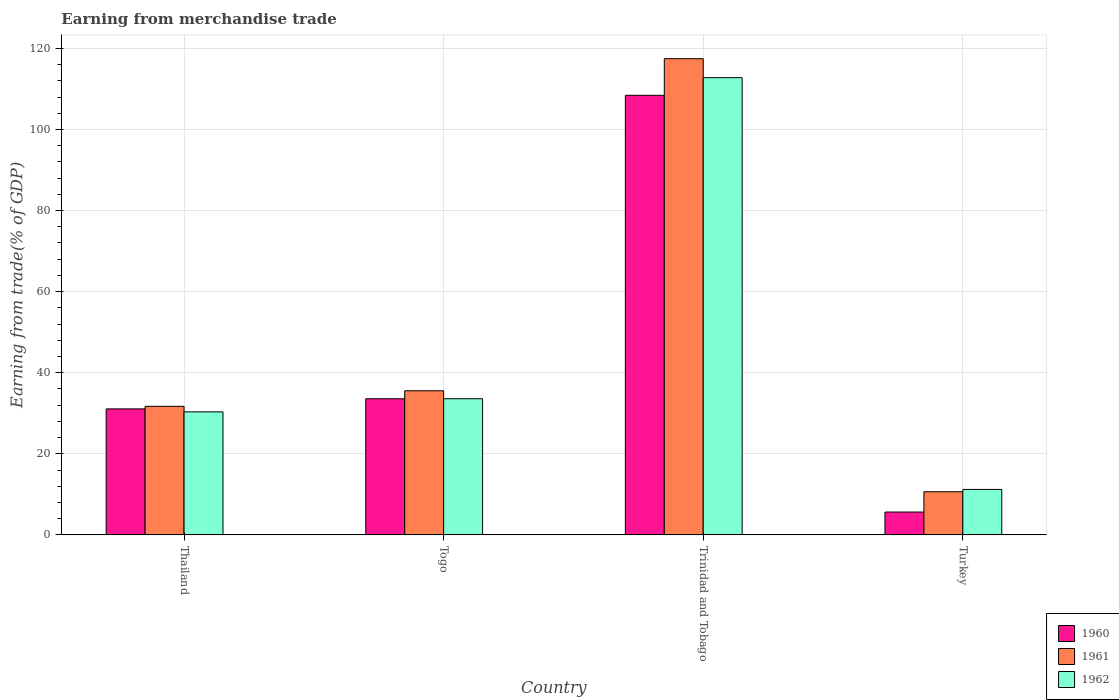How many different coloured bars are there?
Provide a succinct answer. 3. How many groups of bars are there?
Provide a short and direct response. 4. Are the number of bars per tick equal to the number of legend labels?
Ensure brevity in your answer.  Yes. How many bars are there on the 2nd tick from the left?
Your response must be concise. 3. How many bars are there on the 2nd tick from the right?
Provide a short and direct response. 3. What is the label of the 1st group of bars from the left?
Keep it short and to the point. Thailand. In how many cases, is the number of bars for a given country not equal to the number of legend labels?
Your answer should be very brief. 0. What is the earnings from trade in 1962 in Togo?
Ensure brevity in your answer.  33.58. Across all countries, what is the maximum earnings from trade in 1961?
Your response must be concise. 117.45. Across all countries, what is the minimum earnings from trade in 1962?
Ensure brevity in your answer.  11.21. In which country was the earnings from trade in 1960 maximum?
Make the answer very short. Trinidad and Tobago. In which country was the earnings from trade in 1962 minimum?
Ensure brevity in your answer.  Turkey. What is the total earnings from trade in 1960 in the graph?
Ensure brevity in your answer.  178.71. What is the difference between the earnings from trade in 1961 in Thailand and that in Turkey?
Provide a succinct answer. 21.06. What is the difference between the earnings from trade in 1961 in Turkey and the earnings from trade in 1962 in Togo?
Provide a short and direct response. -22.94. What is the average earnings from trade in 1962 per country?
Offer a very short reply. 46.98. What is the difference between the earnings from trade of/in 1962 and earnings from trade of/in 1961 in Togo?
Your response must be concise. -1.96. In how many countries, is the earnings from trade in 1962 greater than 8 %?
Give a very brief answer. 4. What is the ratio of the earnings from trade in 1962 in Togo to that in Trinidad and Tobago?
Make the answer very short. 0.3. What is the difference between the highest and the second highest earnings from trade in 1960?
Offer a very short reply. -74.84. What is the difference between the highest and the lowest earnings from trade in 1961?
Your answer should be very brief. 106.81. Is the sum of the earnings from trade in 1960 in Thailand and Trinidad and Tobago greater than the maximum earnings from trade in 1961 across all countries?
Your response must be concise. Yes. What does the 1st bar from the left in Thailand represents?
Make the answer very short. 1960. What does the 1st bar from the right in Thailand represents?
Make the answer very short. 1962. Does the graph contain any zero values?
Your answer should be very brief. No. Does the graph contain grids?
Offer a terse response. Yes. Where does the legend appear in the graph?
Your answer should be very brief. Bottom right. How many legend labels are there?
Make the answer very short. 3. What is the title of the graph?
Your answer should be very brief. Earning from merchandise trade. Does "2009" appear as one of the legend labels in the graph?
Your answer should be very brief. No. What is the label or title of the X-axis?
Give a very brief answer. Country. What is the label or title of the Y-axis?
Provide a short and direct response. Earning from trade(% of GDP). What is the Earning from trade(% of GDP) in 1960 in Thailand?
Provide a succinct answer. 31.08. What is the Earning from trade(% of GDP) of 1961 in Thailand?
Make the answer very short. 31.71. What is the Earning from trade(% of GDP) of 1962 in Thailand?
Offer a terse response. 30.34. What is the Earning from trade(% of GDP) of 1960 in Togo?
Give a very brief answer. 33.58. What is the Earning from trade(% of GDP) in 1961 in Togo?
Your answer should be very brief. 35.55. What is the Earning from trade(% of GDP) of 1962 in Togo?
Provide a short and direct response. 33.58. What is the Earning from trade(% of GDP) of 1960 in Trinidad and Tobago?
Your answer should be very brief. 108.42. What is the Earning from trade(% of GDP) in 1961 in Trinidad and Tobago?
Offer a very short reply. 117.45. What is the Earning from trade(% of GDP) in 1962 in Trinidad and Tobago?
Make the answer very short. 112.77. What is the Earning from trade(% of GDP) of 1960 in Turkey?
Offer a very short reply. 5.64. What is the Earning from trade(% of GDP) in 1961 in Turkey?
Provide a short and direct response. 10.64. What is the Earning from trade(% of GDP) in 1962 in Turkey?
Make the answer very short. 11.21. Across all countries, what is the maximum Earning from trade(% of GDP) in 1960?
Offer a very short reply. 108.42. Across all countries, what is the maximum Earning from trade(% of GDP) of 1961?
Your answer should be compact. 117.45. Across all countries, what is the maximum Earning from trade(% of GDP) of 1962?
Make the answer very short. 112.77. Across all countries, what is the minimum Earning from trade(% of GDP) in 1960?
Your response must be concise. 5.64. Across all countries, what is the minimum Earning from trade(% of GDP) of 1961?
Your response must be concise. 10.64. Across all countries, what is the minimum Earning from trade(% of GDP) of 1962?
Make the answer very short. 11.21. What is the total Earning from trade(% of GDP) of 1960 in the graph?
Provide a succinct answer. 178.71. What is the total Earning from trade(% of GDP) of 1961 in the graph?
Offer a very short reply. 195.35. What is the total Earning from trade(% of GDP) in 1962 in the graph?
Provide a short and direct response. 187.91. What is the difference between the Earning from trade(% of GDP) in 1960 in Thailand and that in Togo?
Ensure brevity in your answer.  -2.5. What is the difference between the Earning from trade(% of GDP) of 1961 in Thailand and that in Togo?
Your answer should be very brief. -3.84. What is the difference between the Earning from trade(% of GDP) of 1962 in Thailand and that in Togo?
Your answer should be compact. -3.24. What is the difference between the Earning from trade(% of GDP) in 1960 in Thailand and that in Trinidad and Tobago?
Provide a succinct answer. -77.34. What is the difference between the Earning from trade(% of GDP) in 1961 in Thailand and that in Trinidad and Tobago?
Ensure brevity in your answer.  -85.74. What is the difference between the Earning from trade(% of GDP) in 1962 in Thailand and that in Trinidad and Tobago?
Make the answer very short. -82.43. What is the difference between the Earning from trade(% of GDP) in 1960 in Thailand and that in Turkey?
Keep it short and to the point. 25.44. What is the difference between the Earning from trade(% of GDP) in 1961 in Thailand and that in Turkey?
Provide a short and direct response. 21.06. What is the difference between the Earning from trade(% of GDP) of 1962 in Thailand and that in Turkey?
Offer a terse response. 19.13. What is the difference between the Earning from trade(% of GDP) of 1960 in Togo and that in Trinidad and Tobago?
Provide a succinct answer. -74.84. What is the difference between the Earning from trade(% of GDP) in 1961 in Togo and that in Trinidad and Tobago?
Ensure brevity in your answer.  -81.9. What is the difference between the Earning from trade(% of GDP) in 1962 in Togo and that in Trinidad and Tobago?
Keep it short and to the point. -79.19. What is the difference between the Earning from trade(% of GDP) in 1960 in Togo and that in Turkey?
Offer a terse response. 27.94. What is the difference between the Earning from trade(% of GDP) in 1961 in Togo and that in Turkey?
Keep it short and to the point. 24.9. What is the difference between the Earning from trade(% of GDP) in 1962 in Togo and that in Turkey?
Your answer should be very brief. 22.37. What is the difference between the Earning from trade(% of GDP) of 1960 in Trinidad and Tobago and that in Turkey?
Keep it short and to the point. 102.78. What is the difference between the Earning from trade(% of GDP) of 1961 in Trinidad and Tobago and that in Turkey?
Your answer should be compact. 106.81. What is the difference between the Earning from trade(% of GDP) in 1962 in Trinidad and Tobago and that in Turkey?
Your answer should be very brief. 101.56. What is the difference between the Earning from trade(% of GDP) in 1960 in Thailand and the Earning from trade(% of GDP) in 1961 in Togo?
Provide a short and direct response. -4.47. What is the difference between the Earning from trade(% of GDP) in 1960 in Thailand and the Earning from trade(% of GDP) in 1962 in Togo?
Ensure brevity in your answer.  -2.51. What is the difference between the Earning from trade(% of GDP) of 1961 in Thailand and the Earning from trade(% of GDP) of 1962 in Togo?
Your answer should be compact. -1.88. What is the difference between the Earning from trade(% of GDP) of 1960 in Thailand and the Earning from trade(% of GDP) of 1961 in Trinidad and Tobago?
Provide a short and direct response. -86.37. What is the difference between the Earning from trade(% of GDP) in 1960 in Thailand and the Earning from trade(% of GDP) in 1962 in Trinidad and Tobago?
Your response must be concise. -81.69. What is the difference between the Earning from trade(% of GDP) of 1961 in Thailand and the Earning from trade(% of GDP) of 1962 in Trinidad and Tobago?
Provide a succinct answer. -81.07. What is the difference between the Earning from trade(% of GDP) of 1960 in Thailand and the Earning from trade(% of GDP) of 1961 in Turkey?
Offer a very short reply. 20.43. What is the difference between the Earning from trade(% of GDP) of 1960 in Thailand and the Earning from trade(% of GDP) of 1962 in Turkey?
Your answer should be very brief. 19.86. What is the difference between the Earning from trade(% of GDP) in 1961 in Thailand and the Earning from trade(% of GDP) in 1962 in Turkey?
Give a very brief answer. 20.49. What is the difference between the Earning from trade(% of GDP) in 1960 in Togo and the Earning from trade(% of GDP) in 1961 in Trinidad and Tobago?
Ensure brevity in your answer.  -83.87. What is the difference between the Earning from trade(% of GDP) in 1960 in Togo and the Earning from trade(% of GDP) in 1962 in Trinidad and Tobago?
Keep it short and to the point. -79.19. What is the difference between the Earning from trade(% of GDP) of 1961 in Togo and the Earning from trade(% of GDP) of 1962 in Trinidad and Tobago?
Provide a succinct answer. -77.23. What is the difference between the Earning from trade(% of GDP) of 1960 in Togo and the Earning from trade(% of GDP) of 1961 in Turkey?
Your answer should be compact. 22.93. What is the difference between the Earning from trade(% of GDP) in 1960 in Togo and the Earning from trade(% of GDP) in 1962 in Turkey?
Your answer should be compact. 22.36. What is the difference between the Earning from trade(% of GDP) in 1961 in Togo and the Earning from trade(% of GDP) in 1962 in Turkey?
Provide a short and direct response. 24.33. What is the difference between the Earning from trade(% of GDP) of 1960 in Trinidad and Tobago and the Earning from trade(% of GDP) of 1961 in Turkey?
Your answer should be compact. 97.77. What is the difference between the Earning from trade(% of GDP) in 1960 in Trinidad and Tobago and the Earning from trade(% of GDP) in 1962 in Turkey?
Provide a succinct answer. 97.2. What is the difference between the Earning from trade(% of GDP) of 1961 in Trinidad and Tobago and the Earning from trade(% of GDP) of 1962 in Turkey?
Give a very brief answer. 106.24. What is the average Earning from trade(% of GDP) of 1960 per country?
Keep it short and to the point. 44.68. What is the average Earning from trade(% of GDP) of 1961 per country?
Your response must be concise. 48.84. What is the average Earning from trade(% of GDP) in 1962 per country?
Offer a very short reply. 46.98. What is the difference between the Earning from trade(% of GDP) in 1960 and Earning from trade(% of GDP) in 1961 in Thailand?
Offer a very short reply. -0.63. What is the difference between the Earning from trade(% of GDP) of 1960 and Earning from trade(% of GDP) of 1962 in Thailand?
Ensure brevity in your answer.  0.74. What is the difference between the Earning from trade(% of GDP) of 1961 and Earning from trade(% of GDP) of 1962 in Thailand?
Provide a succinct answer. 1.36. What is the difference between the Earning from trade(% of GDP) in 1960 and Earning from trade(% of GDP) in 1961 in Togo?
Your response must be concise. -1.97. What is the difference between the Earning from trade(% of GDP) in 1960 and Earning from trade(% of GDP) in 1962 in Togo?
Ensure brevity in your answer.  -0.01. What is the difference between the Earning from trade(% of GDP) in 1961 and Earning from trade(% of GDP) in 1962 in Togo?
Offer a very short reply. 1.96. What is the difference between the Earning from trade(% of GDP) in 1960 and Earning from trade(% of GDP) in 1961 in Trinidad and Tobago?
Your answer should be very brief. -9.03. What is the difference between the Earning from trade(% of GDP) in 1960 and Earning from trade(% of GDP) in 1962 in Trinidad and Tobago?
Make the answer very short. -4.35. What is the difference between the Earning from trade(% of GDP) of 1961 and Earning from trade(% of GDP) of 1962 in Trinidad and Tobago?
Offer a terse response. 4.68. What is the difference between the Earning from trade(% of GDP) of 1960 and Earning from trade(% of GDP) of 1961 in Turkey?
Offer a terse response. -5.01. What is the difference between the Earning from trade(% of GDP) of 1960 and Earning from trade(% of GDP) of 1962 in Turkey?
Provide a short and direct response. -5.58. What is the difference between the Earning from trade(% of GDP) in 1961 and Earning from trade(% of GDP) in 1962 in Turkey?
Keep it short and to the point. -0.57. What is the ratio of the Earning from trade(% of GDP) in 1960 in Thailand to that in Togo?
Make the answer very short. 0.93. What is the ratio of the Earning from trade(% of GDP) in 1961 in Thailand to that in Togo?
Provide a short and direct response. 0.89. What is the ratio of the Earning from trade(% of GDP) of 1962 in Thailand to that in Togo?
Provide a succinct answer. 0.9. What is the ratio of the Earning from trade(% of GDP) in 1960 in Thailand to that in Trinidad and Tobago?
Provide a succinct answer. 0.29. What is the ratio of the Earning from trade(% of GDP) in 1961 in Thailand to that in Trinidad and Tobago?
Offer a terse response. 0.27. What is the ratio of the Earning from trade(% of GDP) in 1962 in Thailand to that in Trinidad and Tobago?
Your response must be concise. 0.27. What is the ratio of the Earning from trade(% of GDP) of 1960 in Thailand to that in Turkey?
Make the answer very short. 5.51. What is the ratio of the Earning from trade(% of GDP) of 1961 in Thailand to that in Turkey?
Offer a very short reply. 2.98. What is the ratio of the Earning from trade(% of GDP) in 1962 in Thailand to that in Turkey?
Provide a succinct answer. 2.71. What is the ratio of the Earning from trade(% of GDP) in 1960 in Togo to that in Trinidad and Tobago?
Give a very brief answer. 0.31. What is the ratio of the Earning from trade(% of GDP) in 1961 in Togo to that in Trinidad and Tobago?
Your response must be concise. 0.3. What is the ratio of the Earning from trade(% of GDP) of 1962 in Togo to that in Trinidad and Tobago?
Offer a terse response. 0.3. What is the ratio of the Earning from trade(% of GDP) of 1960 in Togo to that in Turkey?
Ensure brevity in your answer.  5.96. What is the ratio of the Earning from trade(% of GDP) in 1961 in Togo to that in Turkey?
Keep it short and to the point. 3.34. What is the ratio of the Earning from trade(% of GDP) in 1962 in Togo to that in Turkey?
Give a very brief answer. 2.99. What is the ratio of the Earning from trade(% of GDP) in 1960 in Trinidad and Tobago to that in Turkey?
Provide a succinct answer. 19.23. What is the ratio of the Earning from trade(% of GDP) of 1961 in Trinidad and Tobago to that in Turkey?
Keep it short and to the point. 11.03. What is the ratio of the Earning from trade(% of GDP) of 1962 in Trinidad and Tobago to that in Turkey?
Your answer should be compact. 10.06. What is the difference between the highest and the second highest Earning from trade(% of GDP) in 1960?
Provide a succinct answer. 74.84. What is the difference between the highest and the second highest Earning from trade(% of GDP) in 1961?
Offer a terse response. 81.9. What is the difference between the highest and the second highest Earning from trade(% of GDP) of 1962?
Your response must be concise. 79.19. What is the difference between the highest and the lowest Earning from trade(% of GDP) in 1960?
Your answer should be very brief. 102.78. What is the difference between the highest and the lowest Earning from trade(% of GDP) of 1961?
Your answer should be very brief. 106.81. What is the difference between the highest and the lowest Earning from trade(% of GDP) in 1962?
Provide a short and direct response. 101.56. 